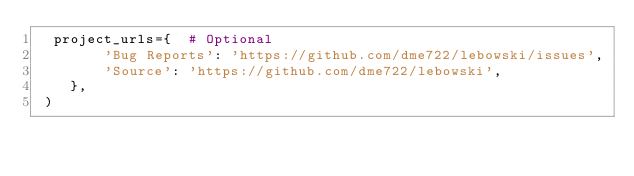<code> <loc_0><loc_0><loc_500><loc_500><_Python_>  project_urls={  # Optional
        'Bug Reports': 'https://github.com/dme722/lebowski/issues',
        'Source': 'https://github.com/dme722/lebowski',
    },
 )</code> 